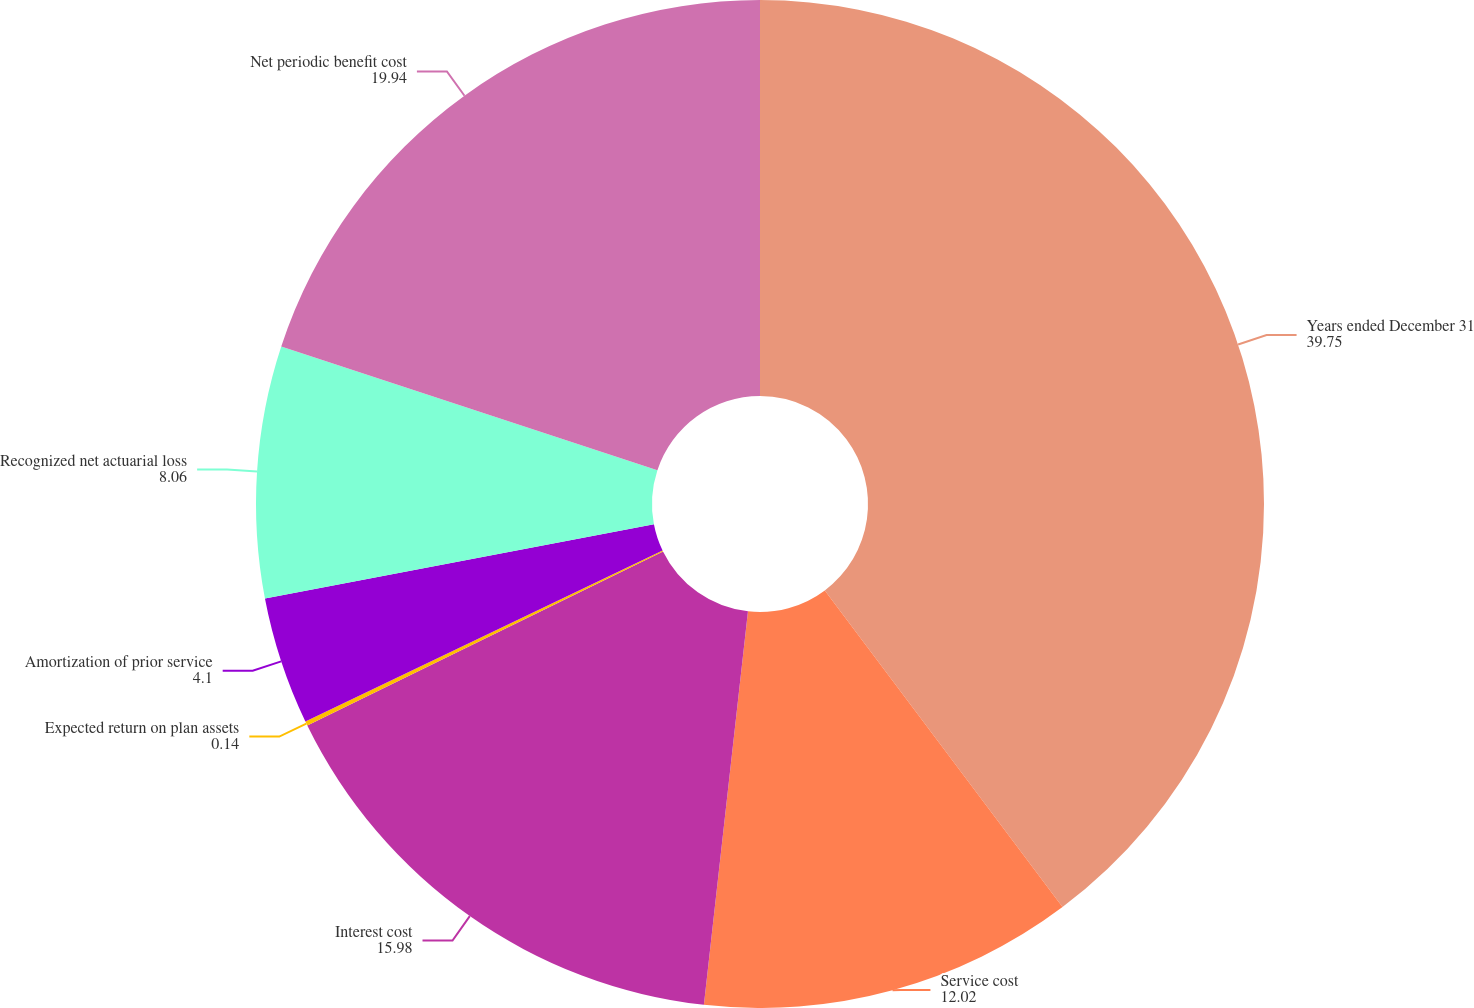Convert chart to OTSL. <chart><loc_0><loc_0><loc_500><loc_500><pie_chart><fcel>Years ended December 31<fcel>Service cost<fcel>Interest cost<fcel>Expected return on plan assets<fcel>Amortization of prior service<fcel>Recognized net actuarial loss<fcel>Net periodic benefit cost<nl><fcel>39.75%<fcel>12.02%<fcel>15.98%<fcel>0.14%<fcel>4.1%<fcel>8.06%<fcel>19.94%<nl></chart> 